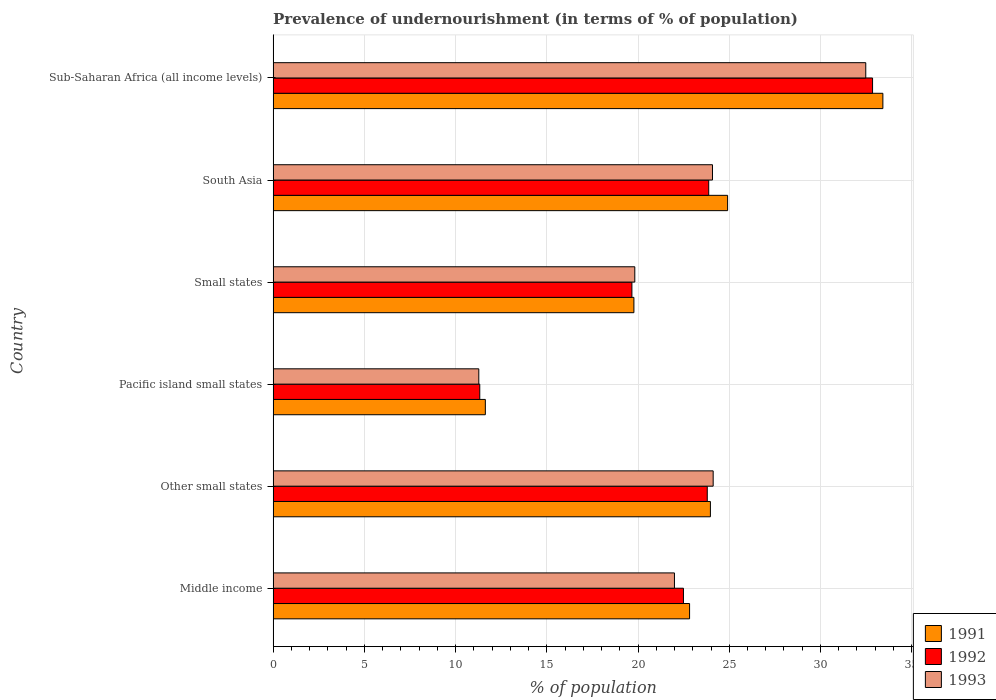How many different coloured bars are there?
Offer a very short reply. 3. How many groups of bars are there?
Your answer should be compact. 6. Are the number of bars per tick equal to the number of legend labels?
Provide a short and direct response. Yes. How many bars are there on the 6th tick from the top?
Make the answer very short. 3. What is the label of the 1st group of bars from the top?
Your answer should be compact. Sub-Saharan Africa (all income levels). In how many cases, is the number of bars for a given country not equal to the number of legend labels?
Offer a terse response. 0. What is the percentage of undernourished population in 1992 in Middle income?
Your response must be concise. 22.49. Across all countries, what is the maximum percentage of undernourished population in 1992?
Provide a short and direct response. 32.86. Across all countries, what is the minimum percentage of undernourished population in 1993?
Your response must be concise. 11.27. In which country was the percentage of undernourished population in 1993 maximum?
Provide a succinct answer. Sub-Saharan Africa (all income levels). In which country was the percentage of undernourished population in 1992 minimum?
Provide a short and direct response. Pacific island small states. What is the total percentage of undernourished population in 1993 in the graph?
Keep it short and to the point. 133.78. What is the difference between the percentage of undernourished population in 1993 in Middle income and that in Small states?
Offer a terse response. 2.17. What is the difference between the percentage of undernourished population in 1992 in Middle income and the percentage of undernourished population in 1991 in Sub-Saharan Africa (all income levels)?
Make the answer very short. -10.93. What is the average percentage of undernourished population in 1993 per country?
Provide a short and direct response. 22.3. What is the difference between the percentage of undernourished population in 1992 and percentage of undernourished population in 1991 in Small states?
Offer a terse response. -0.11. In how many countries, is the percentage of undernourished population in 1993 greater than 23 %?
Offer a very short reply. 3. What is the ratio of the percentage of undernourished population in 1991 in Other small states to that in Pacific island small states?
Provide a succinct answer. 2.06. What is the difference between the highest and the second highest percentage of undernourished population in 1993?
Provide a succinct answer. 8.36. What is the difference between the highest and the lowest percentage of undernourished population in 1993?
Make the answer very short. 21.21. Is the sum of the percentage of undernourished population in 1993 in Pacific island small states and South Asia greater than the maximum percentage of undernourished population in 1992 across all countries?
Make the answer very short. Yes. What does the 3rd bar from the top in South Asia represents?
Ensure brevity in your answer.  1991. How many countries are there in the graph?
Give a very brief answer. 6. What is the difference between two consecutive major ticks on the X-axis?
Your answer should be very brief. 5. Does the graph contain any zero values?
Offer a terse response. No. Does the graph contain grids?
Make the answer very short. Yes. Where does the legend appear in the graph?
Offer a very short reply. Bottom right. How many legend labels are there?
Give a very brief answer. 3. What is the title of the graph?
Keep it short and to the point. Prevalence of undernourishment (in terms of % of population). What is the label or title of the X-axis?
Provide a short and direct response. % of population. What is the % of population in 1991 in Middle income?
Offer a very short reply. 22.83. What is the % of population of 1992 in Middle income?
Make the answer very short. 22.49. What is the % of population in 1993 in Middle income?
Offer a terse response. 22. What is the % of population of 1991 in Other small states?
Offer a terse response. 23.97. What is the % of population in 1992 in Other small states?
Give a very brief answer. 23.8. What is the % of population in 1993 in Other small states?
Make the answer very short. 24.12. What is the % of population of 1991 in Pacific island small states?
Offer a very short reply. 11.63. What is the % of population in 1992 in Pacific island small states?
Offer a very short reply. 11.33. What is the % of population in 1993 in Pacific island small states?
Offer a terse response. 11.27. What is the % of population in 1991 in Small states?
Make the answer very short. 19.77. What is the % of population of 1992 in Small states?
Make the answer very short. 19.66. What is the % of population of 1993 in Small states?
Provide a succinct answer. 19.82. What is the % of population of 1991 in South Asia?
Provide a succinct answer. 24.91. What is the % of population in 1992 in South Asia?
Offer a terse response. 23.88. What is the % of population in 1993 in South Asia?
Provide a succinct answer. 24.08. What is the % of population in 1991 in Sub-Saharan Africa (all income levels)?
Ensure brevity in your answer.  33.42. What is the % of population of 1992 in Sub-Saharan Africa (all income levels)?
Provide a short and direct response. 32.86. What is the % of population in 1993 in Sub-Saharan Africa (all income levels)?
Offer a terse response. 32.48. Across all countries, what is the maximum % of population of 1991?
Your answer should be very brief. 33.42. Across all countries, what is the maximum % of population in 1992?
Your answer should be compact. 32.86. Across all countries, what is the maximum % of population of 1993?
Ensure brevity in your answer.  32.48. Across all countries, what is the minimum % of population in 1991?
Offer a very short reply. 11.63. Across all countries, what is the minimum % of population in 1992?
Ensure brevity in your answer.  11.33. Across all countries, what is the minimum % of population of 1993?
Your answer should be compact. 11.27. What is the total % of population of 1991 in the graph?
Offer a very short reply. 136.53. What is the total % of population of 1992 in the graph?
Offer a very short reply. 134.01. What is the total % of population of 1993 in the graph?
Make the answer very short. 133.78. What is the difference between the % of population in 1991 in Middle income and that in Other small states?
Offer a terse response. -1.14. What is the difference between the % of population of 1992 in Middle income and that in Other small states?
Make the answer very short. -1.3. What is the difference between the % of population in 1993 in Middle income and that in Other small states?
Provide a succinct answer. -2.12. What is the difference between the % of population of 1991 in Middle income and that in Pacific island small states?
Provide a succinct answer. 11.19. What is the difference between the % of population of 1992 in Middle income and that in Pacific island small states?
Give a very brief answer. 11.16. What is the difference between the % of population in 1993 in Middle income and that in Pacific island small states?
Your response must be concise. 10.72. What is the difference between the % of population in 1991 in Middle income and that in Small states?
Offer a very short reply. 3.05. What is the difference between the % of population in 1992 in Middle income and that in Small states?
Your answer should be very brief. 2.83. What is the difference between the % of population of 1993 in Middle income and that in Small states?
Make the answer very short. 2.17. What is the difference between the % of population of 1991 in Middle income and that in South Asia?
Make the answer very short. -2.08. What is the difference between the % of population in 1992 in Middle income and that in South Asia?
Ensure brevity in your answer.  -1.38. What is the difference between the % of population in 1993 in Middle income and that in South Asia?
Ensure brevity in your answer.  -2.08. What is the difference between the % of population of 1991 in Middle income and that in Sub-Saharan Africa (all income levels)?
Offer a terse response. -10.6. What is the difference between the % of population in 1992 in Middle income and that in Sub-Saharan Africa (all income levels)?
Provide a succinct answer. -10.36. What is the difference between the % of population in 1993 in Middle income and that in Sub-Saharan Africa (all income levels)?
Your answer should be compact. -10.49. What is the difference between the % of population in 1991 in Other small states and that in Pacific island small states?
Offer a terse response. 12.34. What is the difference between the % of population in 1992 in Other small states and that in Pacific island small states?
Offer a terse response. 12.47. What is the difference between the % of population of 1993 in Other small states and that in Pacific island small states?
Offer a terse response. 12.85. What is the difference between the % of population in 1991 in Other small states and that in Small states?
Your response must be concise. 4.19. What is the difference between the % of population of 1992 in Other small states and that in Small states?
Offer a very short reply. 4.13. What is the difference between the % of population in 1993 in Other small states and that in Small states?
Your response must be concise. 4.3. What is the difference between the % of population of 1991 in Other small states and that in South Asia?
Give a very brief answer. -0.94. What is the difference between the % of population of 1992 in Other small states and that in South Asia?
Offer a terse response. -0.08. What is the difference between the % of population in 1993 in Other small states and that in South Asia?
Provide a short and direct response. 0.04. What is the difference between the % of population in 1991 in Other small states and that in Sub-Saharan Africa (all income levels)?
Offer a terse response. -9.45. What is the difference between the % of population of 1992 in Other small states and that in Sub-Saharan Africa (all income levels)?
Give a very brief answer. -9.06. What is the difference between the % of population in 1993 in Other small states and that in Sub-Saharan Africa (all income levels)?
Your response must be concise. -8.36. What is the difference between the % of population of 1991 in Pacific island small states and that in Small states?
Provide a short and direct response. -8.14. What is the difference between the % of population of 1992 in Pacific island small states and that in Small states?
Keep it short and to the point. -8.34. What is the difference between the % of population in 1993 in Pacific island small states and that in Small states?
Your answer should be compact. -8.55. What is the difference between the % of population in 1991 in Pacific island small states and that in South Asia?
Your response must be concise. -13.28. What is the difference between the % of population of 1992 in Pacific island small states and that in South Asia?
Keep it short and to the point. -12.55. What is the difference between the % of population in 1993 in Pacific island small states and that in South Asia?
Your response must be concise. -12.81. What is the difference between the % of population in 1991 in Pacific island small states and that in Sub-Saharan Africa (all income levels)?
Your answer should be compact. -21.79. What is the difference between the % of population of 1992 in Pacific island small states and that in Sub-Saharan Africa (all income levels)?
Give a very brief answer. -21.53. What is the difference between the % of population in 1993 in Pacific island small states and that in Sub-Saharan Africa (all income levels)?
Provide a short and direct response. -21.21. What is the difference between the % of population of 1991 in Small states and that in South Asia?
Ensure brevity in your answer.  -5.14. What is the difference between the % of population of 1992 in Small states and that in South Asia?
Your answer should be compact. -4.21. What is the difference between the % of population of 1993 in Small states and that in South Asia?
Your response must be concise. -4.26. What is the difference between the % of population in 1991 in Small states and that in Sub-Saharan Africa (all income levels)?
Provide a short and direct response. -13.65. What is the difference between the % of population in 1992 in Small states and that in Sub-Saharan Africa (all income levels)?
Your answer should be compact. -13.19. What is the difference between the % of population of 1993 in Small states and that in Sub-Saharan Africa (all income levels)?
Offer a terse response. -12.66. What is the difference between the % of population of 1991 in South Asia and that in Sub-Saharan Africa (all income levels)?
Offer a very short reply. -8.51. What is the difference between the % of population of 1992 in South Asia and that in Sub-Saharan Africa (all income levels)?
Your response must be concise. -8.98. What is the difference between the % of population of 1993 in South Asia and that in Sub-Saharan Africa (all income levels)?
Provide a short and direct response. -8.4. What is the difference between the % of population of 1991 in Middle income and the % of population of 1992 in Other small states?
Provide a short and direct response. -0.97. What is the difference between the % of population of 1991 in Middle income and the % of population of 1993 in Other small states?
Your answer should be compact. -1.29. What is the difference between the % of population in 1992 in Middle income and the % of population in 1993 in Other small states?
Your answer should be compact. -1.63. What is the difference between the % of population of 1991 in Middle income and the % of population of 1992 in Pacific island small states?
Give a very brief answer. 11.5. What is the difference between the % of population of 1991 in Middle income and the % of population of 1993 in Pacific island small states?
Provide a short and direct response. 11.55. What is the difference between the % of population of 1992 in Middle income and the % of population of 1993 in Pacific island small states?
Your answer should be compact. 11.22. What is the difference between the % of population in 1991 in Middle income and the % of population in 1992 in Small states?
Your answer should be compact. 3.16. What is the difference between the % of population in 1991 in Middle income and the % of population in 1993 in Small states?
Give a very brief answer. 3. What is the difference between the % of population of 1992 in Middle income and the % of population of 1993 in Small states?
Make the answer very short. 2.67. What is the difference between the % of population in 1991 in Middle income and the % of population in 1992 in South Asia?
Give a very brief answer. -1.05. What is the difference between the % of population in 1991 in Middle income and the % of population in 1993 in South Asia?
Your answer should be compact. -1.26. What is the difference between the % of population in 1992 in Middle income and the % of population in 1993 in South Asia?
Your response must be concise. -1.59. What is the difference between the % of population of 1991 in Middle income and the % of population of 1992 in Sub-Saharan Africa (all income levels)?
Offer a very short reply. -10.03. What is the difference between the % of population of 1991 in Middle income and the % of population of 1993 in Sub-Saharan Africa (all income levels)?
Your answer should be compact. -9.66. What is the difference between the % of population of 1992 in Middle income and the % of population of 1993 in Sub-Saharan Africa (all income levels)?
Your answer should be very brief. -9.99. What is the difference between the % of population in 1991 in Other small states and the % of population in 1992 in Pacific island small states?
Offer a terse response. 12.64. What is the difference between the % of population in 1991 in Other small states and the % of population in 1993 in Pacific island small states?
Provide a succinct answer. 12.69. What is the difference between the % of population of 1992 in Other small states and the % of population of 1993 in Pacific island small states?
Offer a terse response. 12.52. What is the difference between the % of population in 1991 in Other small states and the % of population in 1992 in Small states?
Give a very brief answer. 4.3. What is the difference between the % of population in 1991 in Other small states and the % of population in 1993 in Small states?
Provide a succinct answer. 4.14. What is the difference between the % of population in 1992 in Other small states and the % of population in 1993 in Small states?
Keep it short and to the point. 3.97. What is the difference between the % of population in 1991 in Other small states and the % of population in 1992 in South Asia?
Offer a terse response. 0.09. What is the difference between the % of population in 1991 in Other small states and the % of population in 1993 in South Asia?
Provide a short and direct response. -0.11. What is the difference between the % of population in 1992 in Other small states and the % of population in 1993 in South Asia?
Ensure brevity in your answer.  -0.29. What is the difference between the % of population of 1991 in Other small states and the % of population of 1992 in Sub-Saharan Africa (all income levels)?
Offer a very short reply. -8.89. What is the difference between the % of population in 1991 in Other small states and the % of population in 1993 in Sub-Saharan Africa (all income levels)?
Make the answer very short. -8.51. What is the difference between the % of population of 1992 in Other small states and the % of population of 1993 in Sub-Saharan Africa (all income levels)?
Your answer should be compact. -8.69. What is the difference between the % of population of 1991 in Pacific island small states and the % of population of 1992 in Small states?
Provide a succinct answer. -8.03. What is the difference between the % of population in 1991 in Pacific island small states and the % of population in 1993 in Small states?
Your response must be concise. -8.19. What is the difference between the % of population in 1992 in Pacific island small states and the % of population in 1993 in Small states?
Provide a succinct answer. -8.5. What is the difference between the % of population of 1991 in Pacific island small states and the % of population of 1992 in South Asia?
Offer a terse response. -12.24. What is the difference between the % of population in 1991 in Pacific island small states and the % of population in 1993 in South Asia?
Make the answer very short. -12.45. What is the difference between the % of population in 1992 in Pacific island small states and the % of population in 1993 in South Asia?
Offer a very short reply. -12.76. What is the difference between the % of population in 1991 in Pacific island small states and the % of population in 1992 in Sub-Saharan Africa (all income levels)?
Provide a short and direct response. -21.22. What is the difference between the % of population of 1991 in Pacific island small states and the % of population of 1993 in Sub-Saharan Africa (all income levels)?
Ensure brevity in your answer.  -20.85. What is the difference between the % of population of 1992 in Pacific island small states and the % of population of 1993 in Sub-Saharan Africa (all income levels)?
Give a very brief answer. -21.16. What is the difference between the % of population of 1991 in Small states and the % of population of 1992 in South Asia?
Provide a succinct answer. -4.1. What is the difference between the % of population of 1991 in Small states and the % of population of 1993 in South Asia?
Make the answer very short. -4.31. What is the difference between the % of population in 1992 in Small states and the % of population in 1993 in South Asia?
Make the answer very short. -4.42. What is the difference between the % of population of 1991 in Small states and the % of population of 1992 in Sub-Saharan Africa (all income levels)?
Provide a short and direct response. -13.08. What is the difference between the % of population in 1991 in Small states and the % of population in 1993 in Sub-Saharan Africa (all income levels)?
Ensure brevity in your answer.  -12.71. What is the difference between the % of population of 1992 in Small states and the % of population of 1993 in Sub-Saharan Africa (all income levels)?
Give a very brief answer. -12.82. What is the difference between the % of population of 1991 in South Asia and the % of population of 1992 in Sub-Saharan Africa (all income levels)?
Your response must be concise. -7.95. What is the difference between the % of population of 1991 in South Asia and the % of population of 1993 in Sub-Saharan Africa (all income levels)?
Your answer should be compact. -7.57. What is the difference between the % of population of 1992 in South Asia and the % of population of 1993 in Sub-Saharan Africa (all income levels)?
Offer a terse response. -8.61. What is the average % of population in 1991 per country?
Keep it short and to the point. 22.76. What is the average % of population of 1992 per country?
Offer a very short reply. 22.33. What is the average % of population of 1993 per country?
Your response must be concise. 22.3. What is the difference between the % of population of 1991 and % of population of 1992 in Middle income?
Provide a short and direct response. 0.34. What is the difference between the % of population of 1991 and % of population of 1993 in Middle income?
Your answer should be compact. 0.83. What is the difference between the % of population of 1992 and % of population of 1993 in Middle income?
Keep it short and to the point. 0.49. What is the difference between the % of population of 1991 and % of population of 1992 in Other small states?
Your answer should be compact. 0.17. What is the difference between the % of population of 1991 and % of population of 1993 in Other small states?
Provide a succinct answer. -0.15. What is the difference between the % of population of 1992 and % of population of 1993 in Other small states?
Your response must be concise. -0.32. What is the difference between the % of population of 1991 and % of population of 1992 in Pacific island small states?
Offer a very short reply. 0.31. What is the difference between the % of population of 1991 and % of population of 1993 in Pacific island small states?
Ensure brevity in your answer.  0.36. What is the difference between the % of population of 1992 and % of population of 1993 in Pacific island small states?
Your answer should be very brief. 0.05. What is the difference between the % of population of 1991 and % of population of 1992 in Small states?
Ensure brevity in your answer.  0.11. What is the difference between the % of population of 1991 and % of population of 1993 in Small states?
Your answer should be very brief. -0.05. What is the difference between the % of population of 1992 and % of population of 1993 in Small states?
Ensure brevity in your answer.  -0.16. What is the difference between the % of population in 1991 and % of population in 1992 in South Asia?
Give a very brief answer. 1.04. What is the difference between the % of population of 1991 and % of population of 1993 in South Asia?
Make the answer very short. 0.83. What is the difference between the % of population of 1992 and % of population of 1993 in South Asia?
Your answer should be very brief. -0.21. What is the difference between the % of population of 1991 and % of population of 1992 in Sub-Saharan Africa (all income levels)?
Ensure brevity in your answer.  0.57. What is the difference between the % of population in 1991 and % of population in 1993 in Sub-Saharan Africa (all income levels)?
Your answer should be very brief. 0.94. What is the difference between the % of population in 1992 and % of population in 1993 in Sub-Saharan Africa (all income levels)?
Offer a terse response. 0.37. What is the ratio of the % of population of 1991 in Middle income to that in Other small states?
Provide a succinct answer. 0.95. What is the ratio of the % of population in 1992 in Middle income to that in Other small states?
Ensure brevity in your answer.  0.95. What is the ratio of the % of population of 1993 in Middle income to that in Other small states?
Provide a succinct answer. 0.91. What is the ratio of the % of population in 1991 in Middle income to that in Pacific island small states?
Provide a short and direct response. 1.96. What is the ratio of the % of population in 1992 in Middle income to that in Pacific island small states?
Keep it short and to the point. 1.99. What is the ratio of the % of population in 1993 in Middle income to that in Pacific island small states?
Make the answer very short. 1.95. What is the ratio of the % of population in 1991 in Middle income to that in Small states?
Ensure brevity in your answer.  1.15. What is the ratio of the % of population of 1992 in Middle income to that in Small states?
Provide a short and direct response. 1.14. What is the ratio of the % of population in 1993 in Middle income to that in Small states?
Make the answer very short. 1.11. What is the ratio of the % of population in 1991 in Middle income to that in South Asia?
Your response must be concise. 0.92. What is the ratio of the % of population in 1992 in Middle income to that in South Asia?
Your answer should be very brief. 0.94. What is the ratio of the % of population in 1993 in Middle income to that in South Asia?
Provide a succinct answer. 0.91. What is the ratio of the % of population of 1991 in Middle income to that in Sub-Saharan Africa (all income levels)?
Your answer should be compact. 0.68. What is the ratio of the % of population of 1992 in Middle income to that in Sub-Saharan Africa (all income levels)?
Ensure brevity in your answer.  0.68. What is the ratio of the % of population in 1993 in Middle income to that in Sub-Saharan Africa (all income levels)?
Your answer should be compact. 0.68. What is the ratio of the % of population in 1991 in Other small states to that in Pacific island small states?
Make the answer very short. 2.06. What is the ratio of the % of population of 1992 in Other small states to that in Pacific island small states?
Provide a short and direct response. 2.1. What is the ratio of the % of population of 1993 in Other small states to that in Pacific island small states?
Provide a short and direct response. 2.14. What is the ratio of the % of population of 1991 in Other small states to that in Small states?
Ensure brevity in your answer.  1.21. What is the ratio of the % of population of 1992 in Other small states to that in Small states?
Give a very brief answer. 1.21. What is the ratio of the % of population in 1993 in Other small states to that in Small states?
Ensure brevity in your answer.  1.22. What is the ratio of the % of population of 1991 in Other small states to that in South Asia?
Provide a succinct answer. 0.96. What is the ratio of the % of population of 1991 in Other small states to that in Sub-Saharan Africa (all income levels)?
Your answer should be compact. 0.72. What is the ratio of the % of population in 1992 in Other small states to that in Sub-Saharan Africa (all income levels)?
Your response must be concise. 0.72. What is the ratio of the % of population in 1993 in Other small states to that in Sub-Saharan Africa (all income levels)?
Provide a succinct answer. 0.74. What is the ratio of the % of population of 1991 in Pacific island small states to that in Small states?
Ensure brevity in your answer.  0.59. What is the ratio of the % of population in 1992 in Pacific island small states to that in Small states?
Give a very brief answer. 0.58. What is the ratio of the % of population of 1993 in Pacific island small states to that in Small states?
Your response must be concise. 0.57. What is the ratio of the % of population of 1991 in Pacific island small states to that in South Asia?
Your answer should be compact. 0.47. What is the ratio of the % of population in 1992 in Pacific island small states to that in South Asia?
Provide a short and direct response. 0.47. What is the ratio of the % of population in 1993 in Pacific island small states to that in South Asia?
Your answer should be compact. 0.47. What is the ratio of the % of population in 1991 in Pacific island small states to that in Sub-Saharan Africa (all income levels)?
Offer a terse response. 0.35. What is the ratio of the % of population of 1992 in Pacific island small states to that in Sub-Saharan Africa (all income levels)?
Give a very brief answer. 0.34. What is the ratio of the % of population in 1993 in Pacific island small states to that in Sub-Saharan Africa (all income levels)?
Offer a terse response. 0.35. What is the ratio of the % of population in 1991 in Small states to that in South Asia?
Provide a succinct answer. 0.79. What is the ratio of the % of population of 1992 in Small states to that in South Asia?
Your response must be concise. 0.82. What is the ratio of the % of population in 1993 in Small states to that in South Asia?
Provide a short and direct response. 0.82. What is the ratio of the % of population in 1991 in Small states to that in Sub-Saharan Africa (all income levels)?
Give a very brief answer. 0.59. What is the ratio of the % of population in 1992 in Small states to that in Sub-Saharan Africa (all income levels)?
Make the answer very short. 0.6. What is the ratio of the % of population of 1993 in Small states to that in Sub-Saharan Africa (all income levels)?
Provide a short and direct response. 0.61. What is the ratio of the % of population of 1991 in South Asia to that in Sub-Saharan Africa (all income levels)?
Your answer should be compact. 0.75. What is the ratio of the % of population in 1992 in South Asia to that in Sub-Saharan Africa (all income levels)?
Your answer should be compact. 0.73. What is the ratio of the % of population of 1993 in South Asia to that in Sub-Saharan Africa (all income levels)?
Offer a very short reply. 0.74. What is the difference between the highest and the second highest % of population in 1991?
Offer a terse response. 8.51. What is the difference between the highest and the second highest % of population in 1992?
Your answer should be compact. 8.98. What is the difference between the highest and the second highest % of population of 1993?
Your answer should be compact. 8.36. What is the difference between the highest and the lowest % of population of 1991?
Provide a short and direct response. 21.79. What is the difference between the highest and the lowest % of population of 1992?
Give a very brief answer. 21.53. What is the difference between the highest and the lowest % of population in 1993?
Your answer should be compact. 21.21. 